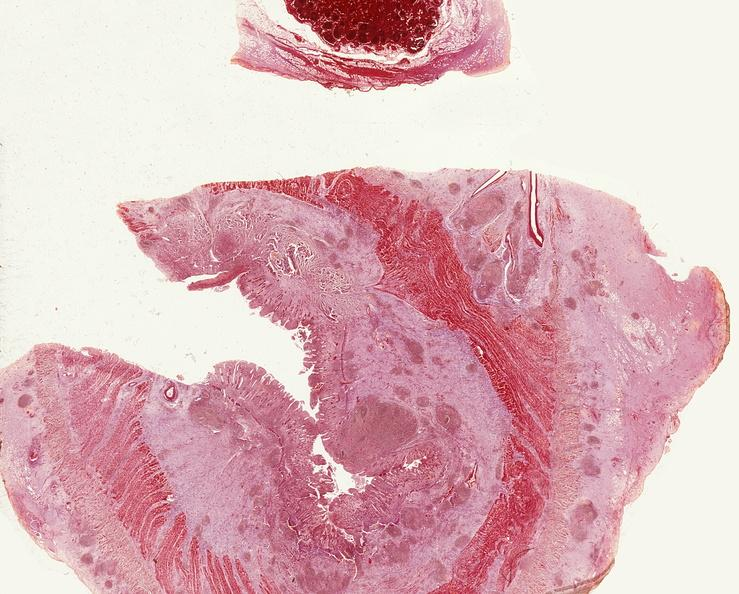what is present?
Answer the question using a single word or phrase. Gastrointestinal 